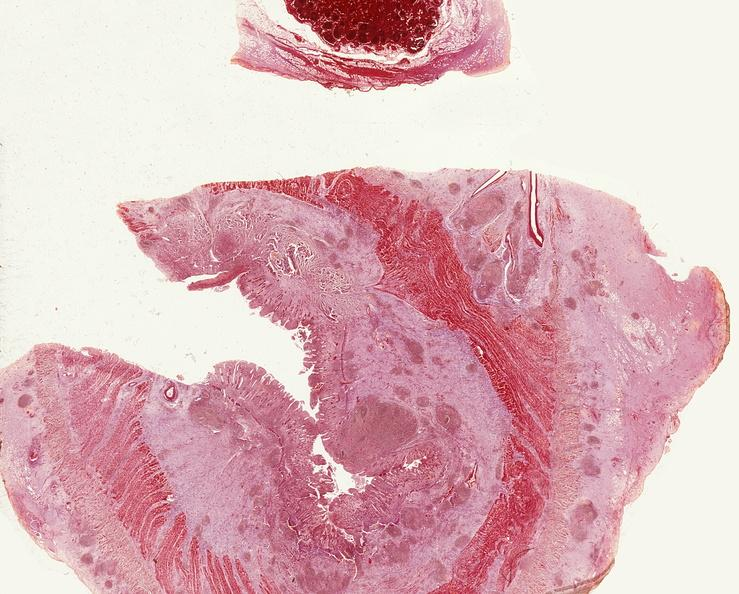what is present?
Answer the question using a single word or phrase. Gastrointestinal 